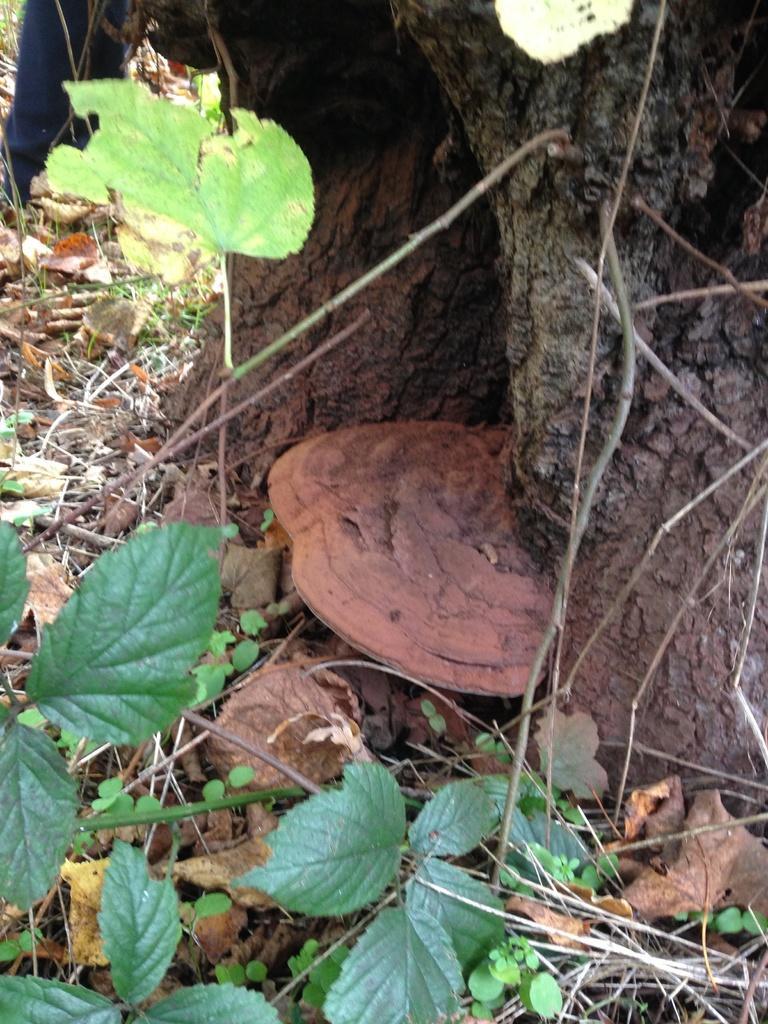Please provide a concise description of this image. In this picture there is a tree and there is an object. At the bottom there are plants, dried leaves and sticks. 